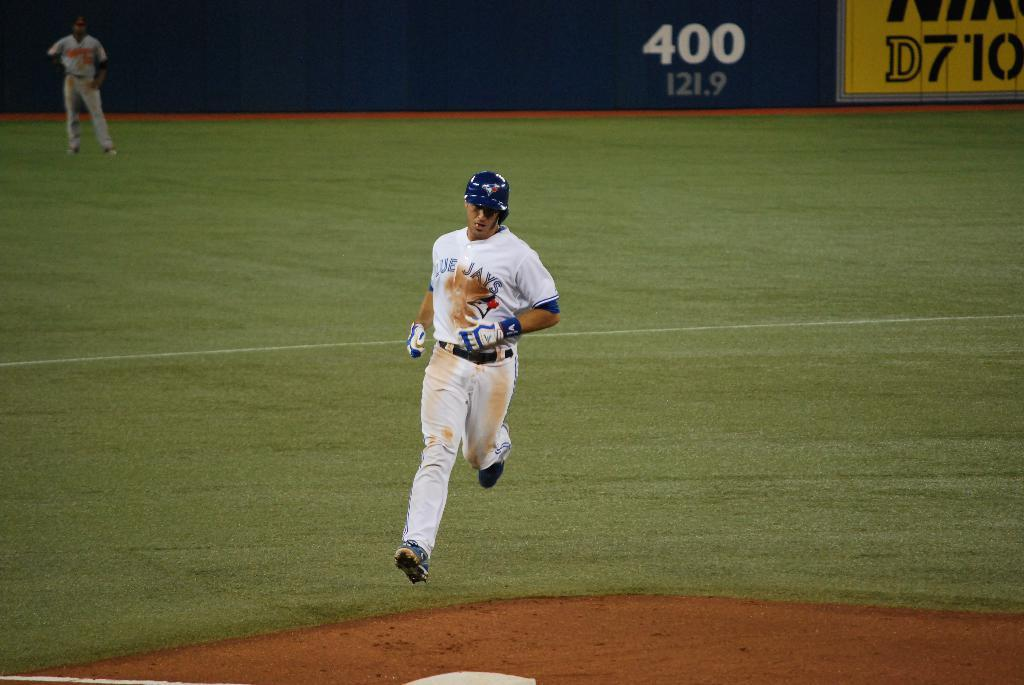<image>
Give a short and clear explanation of the subsequent image. A Blue Jays player running on the field. 